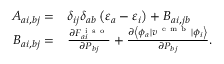<formula> <loc_0><loc_0><loc_500><loc_500>\begin{array} { r l } { A _ { a i , b j } = } & \delta _ { i j } \delta _ { a b } \left ( \varepsilon _ { a } - \varepsilon _ { i } \right ) + B _ { a i , j b } } \\ { B _ { a i , b j } = } & \frac { \partial F _ { a i } ^ { i s o } } { \partial P _ { b j } } + \frac { \partial \left \langle \phi _ { a } | { v } ^ { e m b } | \phi _ { i } \right \rangle } { \partial P _ { b j } } . } \end{array}</formula> 